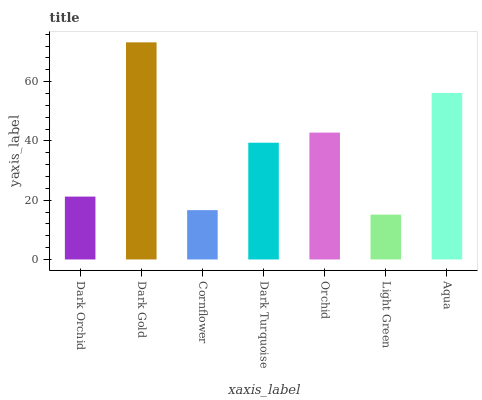Is Light Green the minimum?
Answer yes or no. Yes. Is Dark Gold the maximum?
Answer yes or no. Yes. Is Cornflower the minimum?
Answer yes or no. No. Is Cornflower the maximum?
Answer yes or no. No. Is Dark Gold greater than Cornflower?
Answer yes or no. Yes. Is Cornflower less than Dark Gold?
Answer yes or no. Yes. Is Cornflower greater than Dark Gold?
Answer yes or no. No. Is Dark Gold less than Cornflower?
Answer yes or no. No. Is Dark Turquoise the high median?
Answer yes or no. Yes. Is Dark Turquoise the low median?
Answer yes or no. Yes. Is Cornflower the high median?
Answer yes or no. No. Is Light Green the low median?
Answer yes or no. No. 